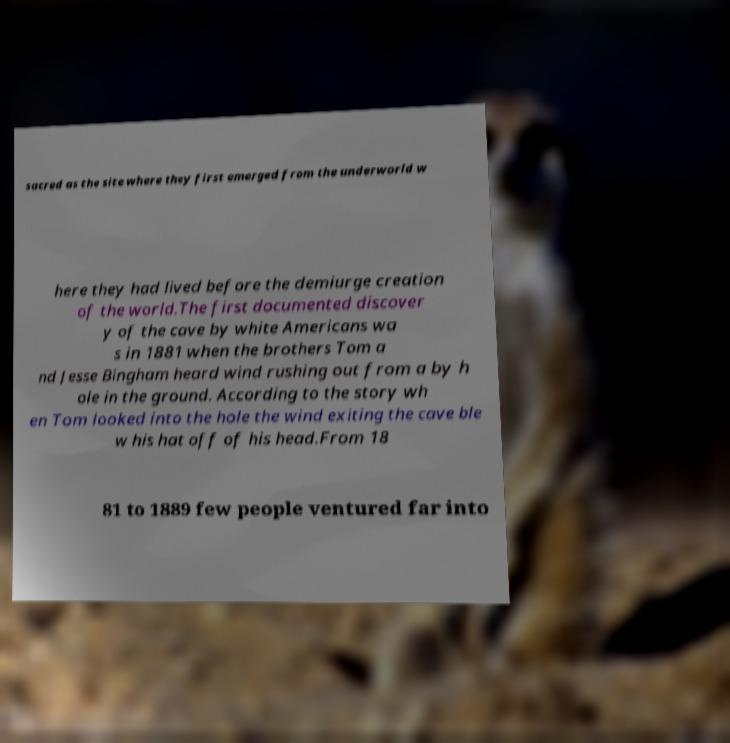Could you extract and type out the text from this image? sacred as the site where they first emerged from the underworld w here they had lived before the demiurge creation of the world.The first documented discover y of the cave by white Americans wa s in 1881 when the brothers Tom a nd Jesse Bingham heard wind rushing out from a by h ole in the ground. According to the story wh en Tom looked into the hole the wind exiting the cave ble w his hat off of his head.From 18 81 to 1889 few people ventured far into 